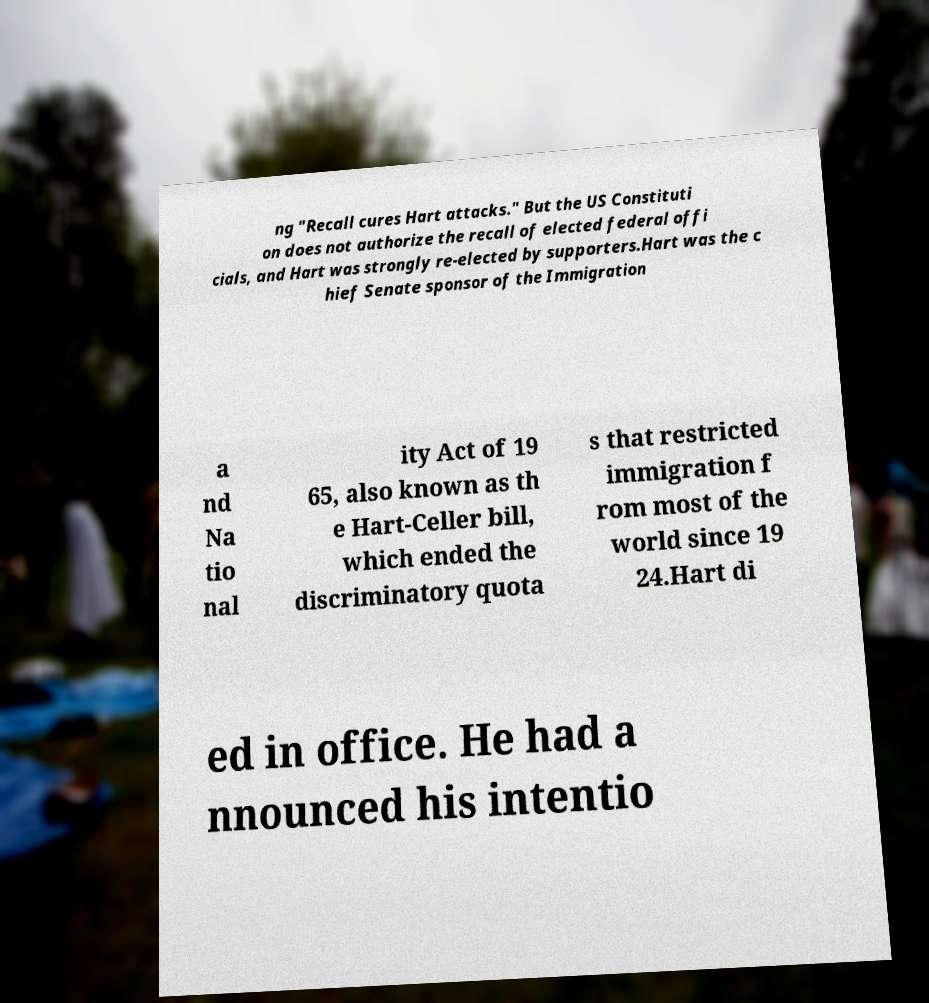Could you assist in decoding the text presented in this image and type it out clearly? ng "Recall cures Hart attacks." But the US Constituti on does not authorize the recall of elected federal offi cials, and Hart was strongly re-elected by supporters.Hart was the c hief Senate sponsor of the Immigration a nd Na tio nal ity Act of 19 65, also known as th e Hart-Celler bill, which ended the discriminatory quota s that restricted immigration f rom most of the world since 19 24.Hart di ed in office. He had a nnounced his intentio 